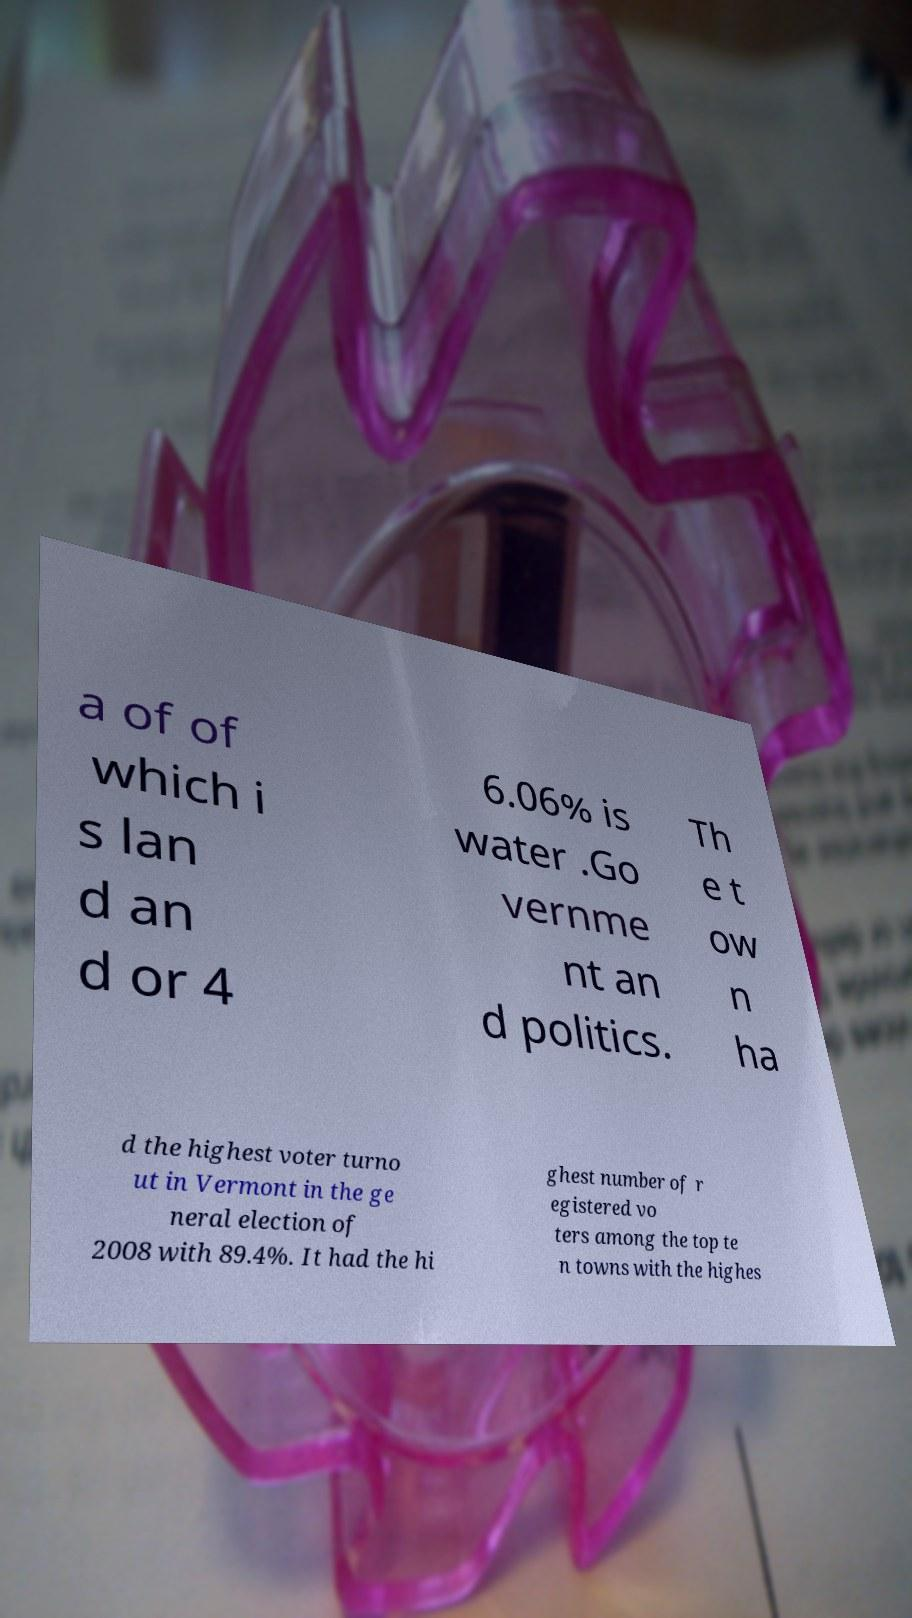What messages or text are displayed in this image? I need them in a readable, typed format. a of of which i s lan d an d or 4 6.06% is water .Go vernme nt an d politics. Th e t ow n ha d the highest voter turno ut in Vermont in the ge neral election of 2008 with 89.4%. It had the hi ghest number of r egistered vo ters among the top te n towns with the highes 